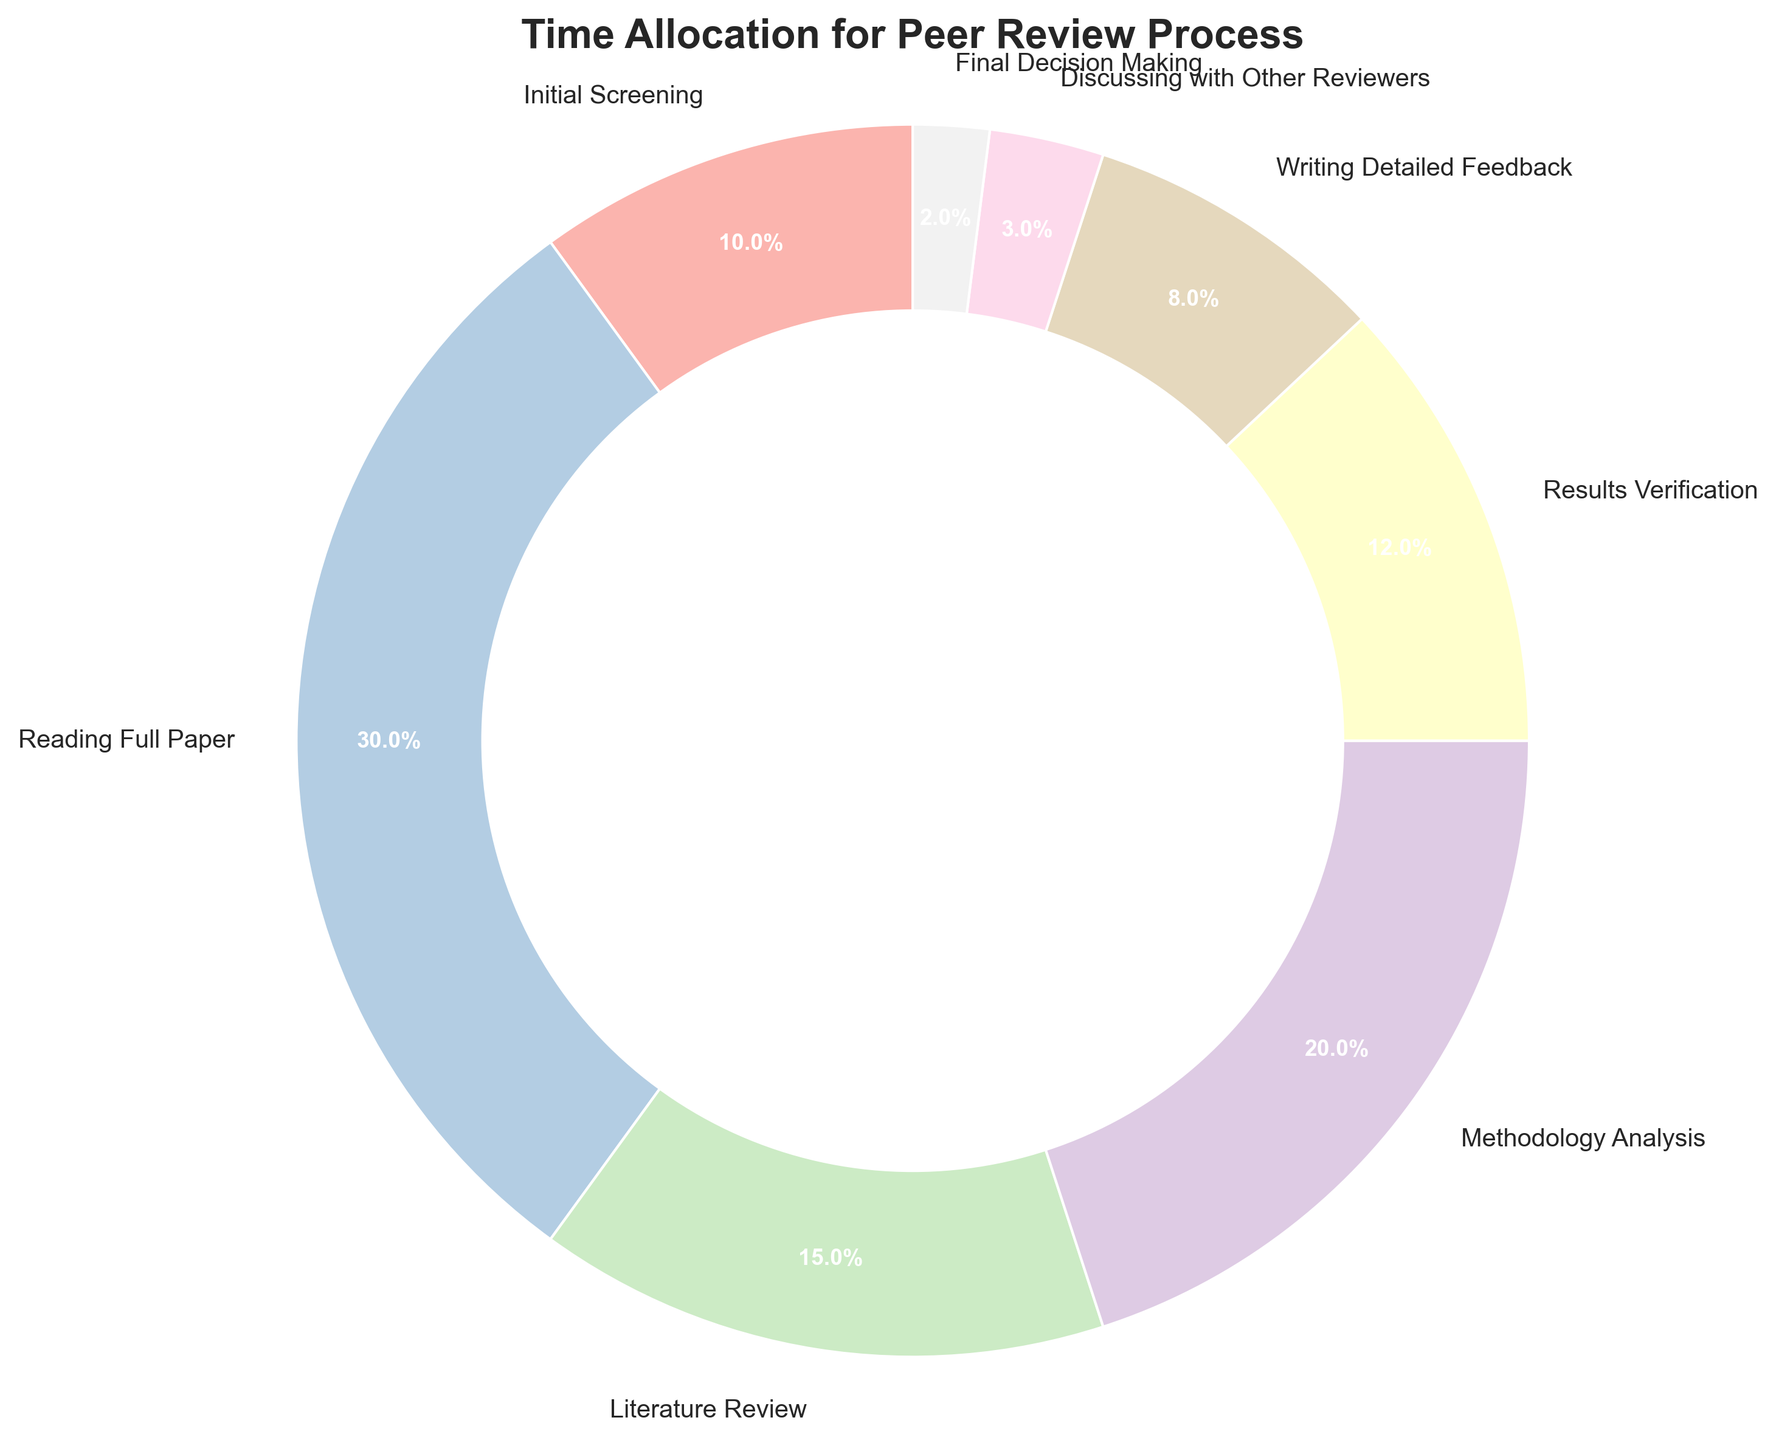Which phase takes up the largest percentage of time in the peer review process? By examining the pie chart, we can see that the "Reading Full Paper" phase has the largest slice of the pie, which is labeled with 30%.
Answer: Reading Full Paper What is the combined percentage of time spent on "Methodology Analysis" and "Results Verification"? The pie slices labeled "Methodology Analysis" and "Results Verification" show percentages of 20% and 12% respectively. Adding these values together gives 20% + 12% = 32%.
Answer: 32% How much more time is allocated to "Reading Full Paper" compared to "Writing Detailed Feedback"? "Reading Full Paper" has a labeled percentage of 30%, while "Writing Detailed Feedback" has 8%. The difference between these two percentages is 30% - 8% = 22%.
Answer: 22% Which phases account for less than 10% of the total time each? By looking at the labeled slices, the phases with percentages less than 10% are "Initial Screening" (10%), "Writing Detailed Feedback" (8%), "Discussing with Other Reviewers" (3%), and "Final Decision Making" (2%). Since "Initial Screening" is exactly 10%, it is not included.
Answer: Writing Detailed Feedback, Discussing with Other Reviewers, Final Decision Making What is the total percentage of time spent on "Discussing with Other Reviewers" and "Final Decision Making"? The percentages for these phases are labeled as 3% and 2%, respectively. Adding them together gives 3% + 2% = 5%.
Answer: 5% Which visual element indicates the percentage of each phase in the pie chart? Each slice of the pie is labeled with its corresponding percentage. The size of each slice is proportional to the percentage it represents.
Answer: Slice labels What phase has the smallest percentage and what is that percentage? By examining the pie chart, the smallest slice is for the "Final Decision Making" phase, which is labeled as 2%.
Answer: Final Decision Making, 2% If the time for "Literature Review" and "Methodology Analysis" were combined, would it form the largest slice? The percentages for "Literature Review" and "Methodology Analysis" are 15% and 20%, respectively. Adding them gives 15% + 20% = 35%. Since the largest existing slice, "Reading Full Paper," is 30%, the combined slices would indeed form the largest slice.
Answer: Yes 